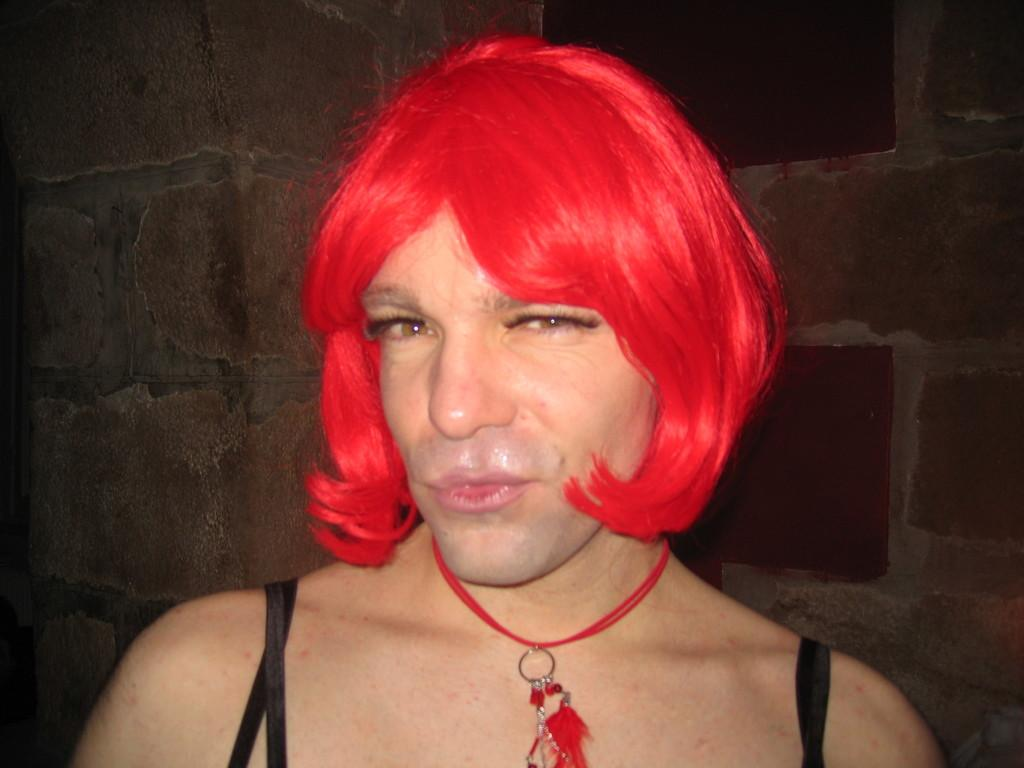What is the main subject of the image? There is a person in the image. What is the person doing in the image? The person is smiling and giving a pose for the picture. What can be seen in the background of the image? There is a wall in the background of the image. What is the color of the person's hair? The person's hair is in red color. What type of notebook is the person holding in the image? There is no notebook present in the image. What type of polish is the person applying to their nails in the image? There is no indication of nail polish or any polishing activity in the image. 